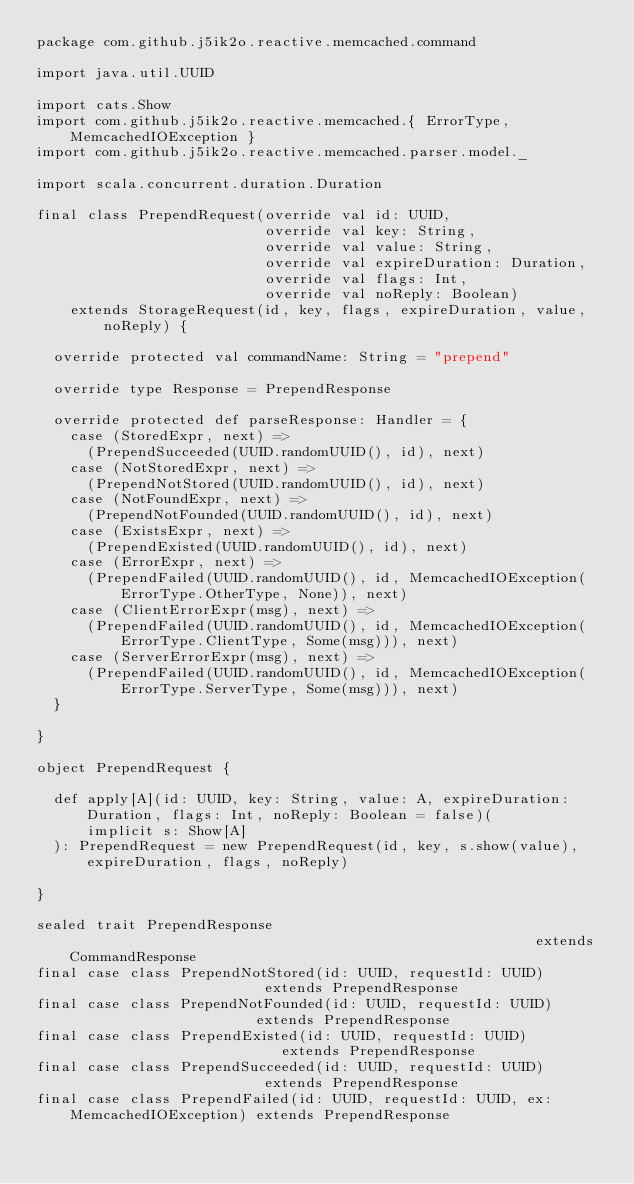<code> <loc_0><loc_0><loc_500><loc_500><_Scala_>package com.github.j5ik2o.reactive.memcached.command

import java.util.UUID

import cats.Show
import com.github.j5ik2o.reactive.memcached.{ ErrorType, MemcachedIOException }
import com.github.j5ik2o.reactive.memcached.parser.model._

import scala.concurrent.duration.Duration

final class PrependRequest(override val id: UUID,
                           override val key: String,
                           override val value: String,
                           override val expireDuration: Duration,
                           override val flags: Int,
                           override val noReply: Boolean)
    extends StorageRequest(id, key, flags, expireDuration, value, noReply) {

  override protected val commandName: String = "prepend"

  override type Response = PrependResponse

  override protected def parseResponse: Handler = {
    case (StoredExpr, next) =>
      (PrependSucceeded(UUID.randomUUID(), id), next)
    case (NotStoredExpr, next) =>
      (PrependNotStored(UUID.randomUUID(), id), next)
    case (NotFoundExpr, next) =>
      (PrependNotFounded(UUID.randomUUID(), id), next)
    case (ExistsExpr, next) =>
      (PrependExisted(UUID.randomUUID(), id), next)
    case (ErrorExpr, next) =>
      (PrependFailed(UUID.randomUUID(), id, MemcachedIOException(ErrorType.OtherType, None)), next)
    case (ClientErrorExpr(msg), next) =>
      (PrependFailed(UUID.randomUUID(), id, MemcachedIOException(ErrorType.ClientType, Some(msg))), next)
    case (ServerErrorExpr(msg), next) =>
      (PrependFailed(UUID.randomUUID(), id, MemcachedIOException(ErrorType.ServerType, Some(msg))), next)
  }

}

object PrependRequest {

  def apply[A](id: UUID, key: String, value: A, expireDuration: Duration, flags: Int, noReply: Boolean = false)(
      implicit s: Show[A]
  ): PrependRequest = new PrependRequest(id, key, s.show(value), expireDuration, flags, noReply)

}

sealed trait PrependResponse                                                        extends CommandResponse
final case class PrependNotStored(id: UUID, requestId: UUID)                        extends PrependResponse
final case class PrependNotFounded(id: UUID, requestId: UUID)                       extends PrependResponse
final case class PrependExisted(id: UUID, requestId: UUID)                          extends PrependResponse
final case class PrependSucceeded(id: UUID, requestId: UUID)                        extends PrependResponse
final case class PrependFailed(id: UUID, requestId: UUID, ex: MemcachedIOException) extends PrependResponse
</code> 